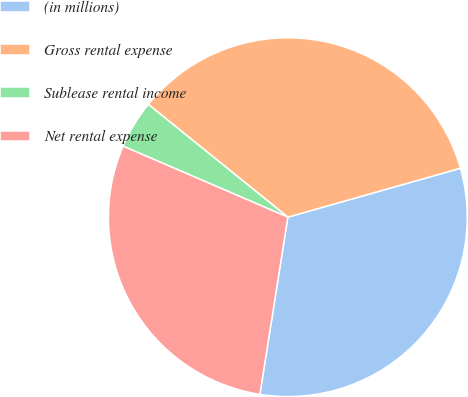Convert chart. <chart><loc_0><loc_0><loc_500><loc_500><pie_chart><fcel>(in millions)<fcel>Gross rental expense<fcel>Sublease rental income<fcel>Net rental expense<nl><fcel>31.89%<fcel>34.79%<fcel>4.34%<fcel>28.99%<nl></chart> 